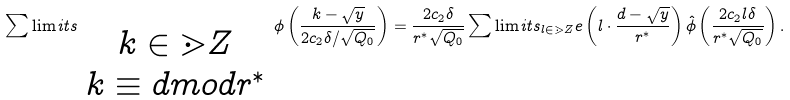Convert formula to latex. <formula><loc_0><loc_0><loc_500><loc_500>\sum \lim i t s _ { \begin{array} { c c c c } k \in \mathbb { m } { Z } \\ k \equiv d m o d r ^ { * } \end{array} } \phi \left ( \frac { k - \sqrt { y } } { 2 c _ { 2 } \delta / \sqrt { Q _ { 0 } } } \right ) = \frac { 2 c _ { 2 } \delta } { r ^ { * } \sqrt { Q _ { 0 } } } \sum \lim i t s _ { l \in \mathbb { m } { Z } } e \left ( l \cdot \frac { d - \sqrt { y } } { r ^ { * } } \right ) \hat { \phi } \left ( \frac { 2 c _ { 2 } l \delta } { r ^ { * } \sqrt { Q _ { 0 } } } \right ) .</formula> 